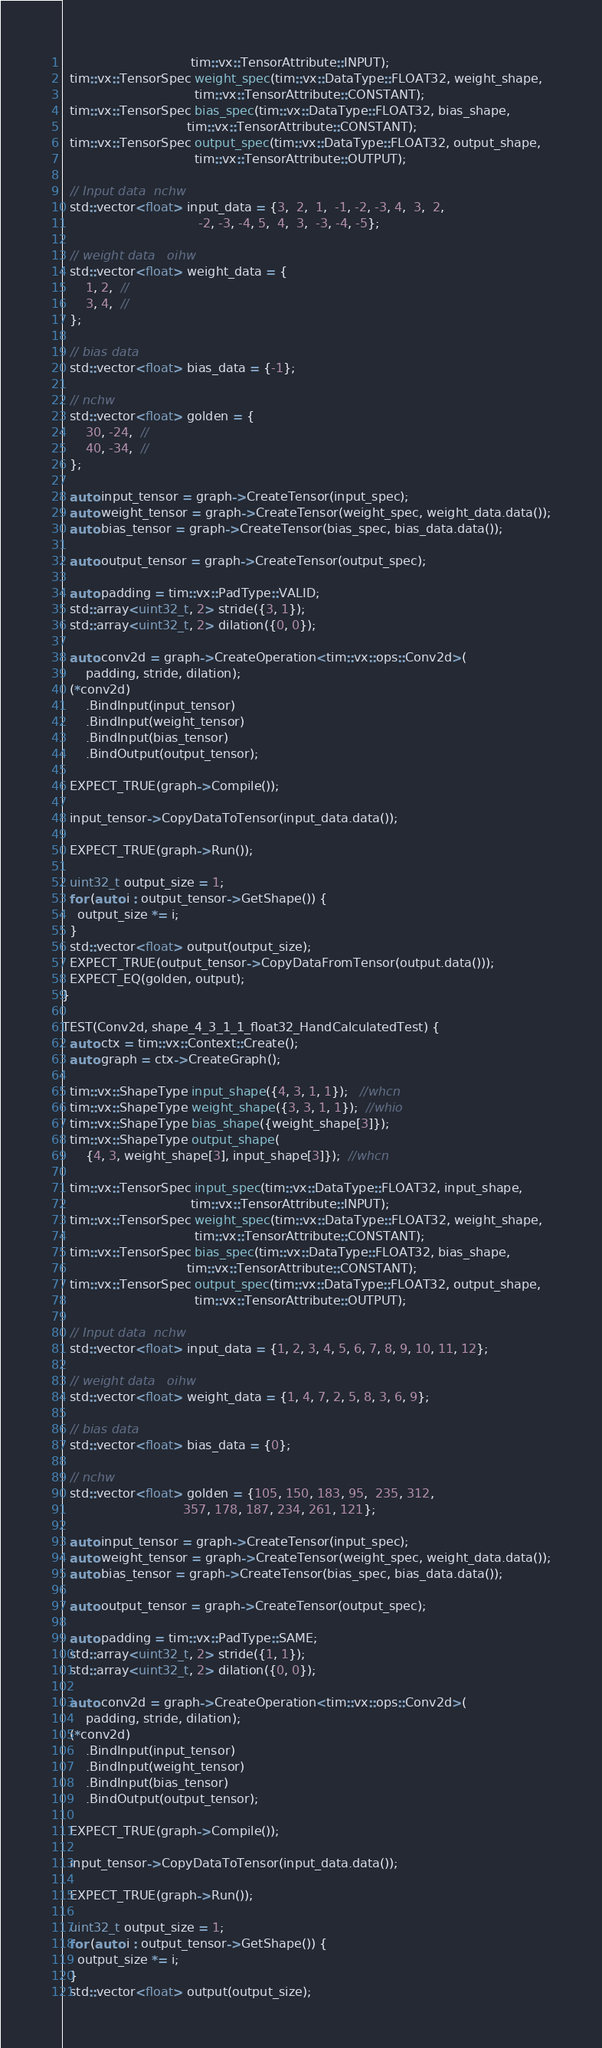<code> <loc_0><loc_0><loc_500><loc_500><_C++_>                                 tim::vx::TensorAttribute::INPUT);
  tim::vx::TensorSpec weight_spec(tim::vx::DataType::FLOAT32, weight_shape,
                                  tim::vx::TensorAttribute::CONSTANT);
  tim::vx::TensorSpec bias_spec(tim::vx::DataType::FLOAT32, bias_shape,
                                tim::vx::TensorAttribute::CONSTANT);
  tim::vx::TensorSpec output_spec(tim::vx::DataType::FLOAT32, output_shape,
                                  tim::vx::TensorAttribute::OUTPUT);

  // Input data  nchw
  std::vector<float> input_data = {3,  2,  1,  -1, -2, -3, 4,  3,  2,
                                   -2, -3, -4, 5,  4,  3,  -3, -4, -5};

  // weight data   oihw
  std::vector<float> weight_data = {
      1, 2,  //
      3, 4,  //
  };

  // bias data
  std::vector<float> bias_data = {-1};

  // nchw
  std::vector<float> golden = {
      30, -24,  //
      40, -34,  //
  };

  auto input_tensor = graph->CreateTensor(input_spec);
  auto weight_tensor = graph->CreateTensor(weight_spec, weight_data.data());
  auto bias_tensor = graph->CreateTensor(bias_spec, bias_data.data());

  auto output_tensor = graph->CreateTensor(output_spec);

  auto padding = tim::vx::PadType::VALID;
  std::array<uint32_t, 2> stride({3, 1});
  std::array<uint32_t, 2> dilation({0, 0});

  auto conv2d = graph->CreateOperation<tim::vx::ops::Conv2d>(
      padding, stride, dilation);
  (*conv2d)
      .BindInput(input_tensor)
      .BindInput(weight_tensor)
      .BindInput(bias_tensor)
      .BindOutput(output_tensor);

  EXPECT_TRUE(graph->Compile());

  input_tensor->CopyDataToTensor(input_data.data());

  EXPECT_TRUE(graph->Run());

  uint32_t output_size = 1;
  for (auto i : output_tensor->GetShape()) {
    output_size *= i;
  }
  std::vector<float> output(output_size);
  EXPECT_TRUE(output_tensor->CopyDataFromTensor(output.data()));
  EXPECT_EQ(golden, output);
}

TEST(Conv2d, shape_4_3_1_1_float32_HandCalculatedTest) {
  auto ctx = tim::vx::Context::Create();
  auto graph = ctx->CreateGraph();

  tim::vx::ShapeType input_shape({4, 3, 1, 1});   //whcn
  tim::vx::ShapeType weight_shape({3, 3, 1, 1});  //whio
  tim::vx::ShapeType bias_shape({weight_shape[3]});
  tim::vx::ShapeType output_shape(
      {4, 3, weight_shape[3], input_shape[3]});  //whcn

  tim::vx::TensorSpec input_spec(tim::vx::DataType::FLOAT32, input_shape,
                                 tim::vx::TensorAttribute::INPUT);
  tim::vx::TensorSpec weight_spec(tim::vx::DataType::FLOAT32, weight_shape,
                                  tim::vx::TensorAttribute::CONSTANT);
  tim::vx::TensorSpec bias_spec(tim::vx::DataType::FLOAT32, bias_shape,
                                tim::vx::TensorAttribute::CONSTANT);
  tim::vx::TensorSpec output_spec(tim::vx::DataType::FLOAT32, output_shape,
                                  tim::vx::TensorAttribute::OUTPUT);

  // Input data  nchw
  std::vector<float> input_data = {1, 2, 3, 4, 5, 6, 7, 8, 9, 10, 11, 12};

  // weight data   oihw
  std::vector<float> weight_data = {1, 4, 7, 2, 5, 8, 3, 6, 9};

  // bias data
  std::vector<float> bias_data = {0};

  // nchw
  std::vector<float> golden = {105, 150, 183, 95,  235, 312,
                               357, 178, 187, 234, 261, 121};

  auto input_tensor = graph->CreateTensor(input_spec);
  auto weight_tensor = graph->CreateTensor(weight_spec, weight_data.data());
  auto bias_tensor = graph->CreateTensor(bias_spec, bias_data.data());

  auto output_tensor = graph->CreateTensor(output_spec);

  auto padding = tim::vx::PadType::SAME;
  std::array<uint32_t, 2> stride({1, 1});
  std::array<uint32_t, 2> dilation({0, 0});

  auto conv2d = graph->CreateOperation<tim::vx::ops::Conv2d>(
      padding, stride, dilation);
  (*conv2d)
      .BindInput(input_tensor)
      .BindInput(weight_tensor)
      .BindInput(bias_tensor)
      .BindOutput(output_tensor);

  EXPECT_TRUE(graph->Compile());

  input_tensor->CopyDataToTensor(input_data.data());

  EXPECT_TRUE(graph->Run());

  uint32_t output_size = 1;
  for (auto i : output_tensor->GetShape()) {
    output_size *= i;
  }
  std::vector<float> output(output_size);</code> 